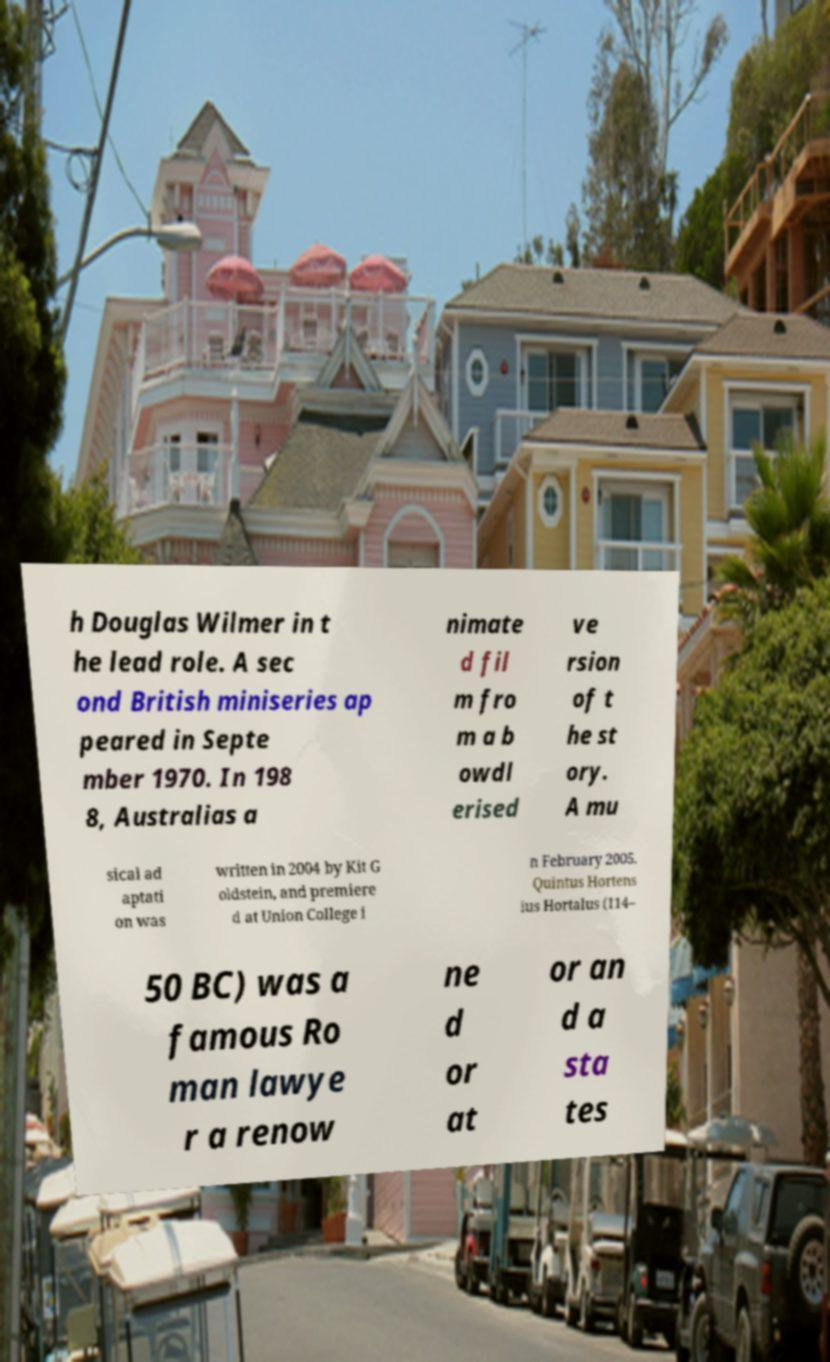Please identify and transcribe the text found in this image. h Douglas Wilmer in t he lead role. A sec ond British miniseries ap peared in Septe mber 1970. In 198 8, Australias a nimate d fil m fro m a b owdl erised ve rsion of t he st ory. A mu sical ad aptati on was written in 2004 by Kit G oldstein, and premiere d at Union College i n February 2005. Quintus Hortens ius Hortalus (114– 50 BC) was a famous Ro man lawye r a renow ne d or at or an d a sta tes 